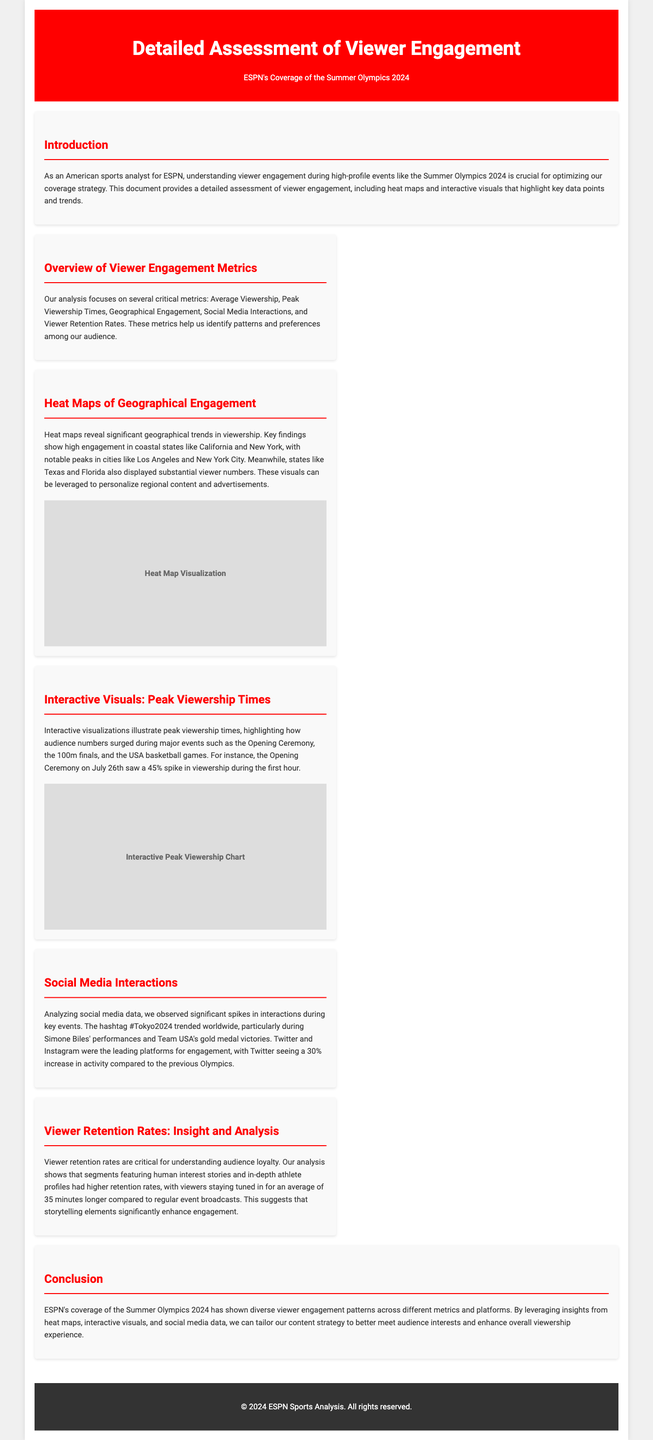what is the primary focus of the document? The document focuses on understanding viewer engagement during ESPN's coverage of the Summer Olympics 2024.
Answer: viewer engagement which two states showed high geographical engagement? The document mentions California and New York as having high engagement in viewership.
Answer: California and New York what significant event had a 45% spike in viewership? The Opening Ceremony on July 26th saw a notable increase in viewership during its first hour.
Answer: Opening Ceremony which social media platform saw a 30% increase in activity? The document highlights that Twitter experienced a significant rise in engagement compared to previous Olympics.
Answer: Twitter what is the average increase in viewer retention for segments featuring human interest stories? The analysis shows that viewers stayed tuned in for an average of 35 minutes longer with these segments.
Answer: 35 minutes how does the document suggest enhancing overall viewership experience? Insights from heat maps, interactive visuals, and social media data can help tailor content strategy.
Answer: content strategy what tool is used to visualize geographical trends in viewership? The document refers to heat maps as a tool for revealing engagement trends.
Answer: heat maps when did the USA basketball games occur in relation to peak viewership? The USA basketball games are highlighted as major events but no specific date is provided for peak times within the document.
Answer: Not specified what is the title of the document? The title specifically outlines the assessment conducted during ESPN's coverage of the Olympics.
Answer: Detailed Assessment of Viewer Engagement 